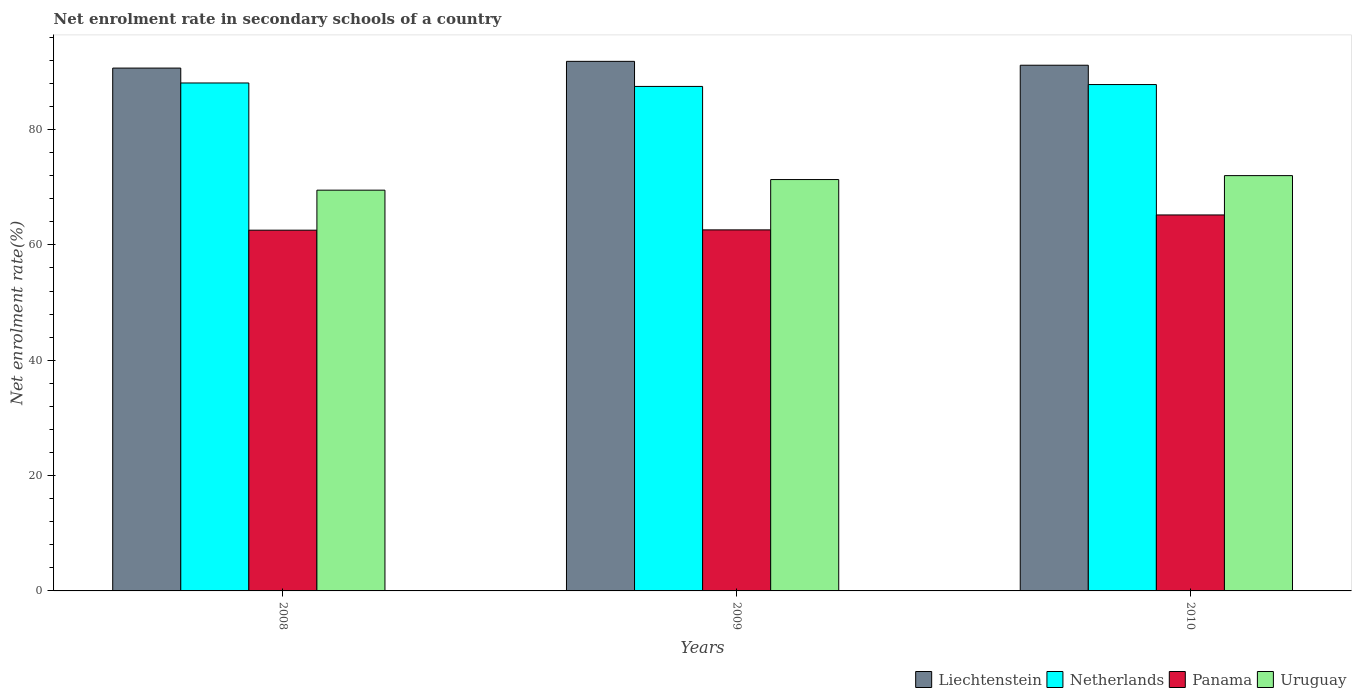How many different coloured bars are there?
Make the answer very short. 4. Are the number of bars per tick equal to the number of legend labels?
Offer a very short reply. Yes. How many bars are there on the 1st tick from the right?
Give a very brief answer. 4. What is the label of the 2nd group of bars from the left?
Make the answer very short. 2009. In how many cases, is the number of bars for a given year not equal to the number of legend labels?
Keep it short and to the point. 0. What is the net enrolment rate in secondary schools in Netherlands in 2010?
Ensure brevity in your answer.  87.8. Across all years, what is the maximum net enrolment rate in secondary schools in Netherlands?
Your answer should be very brief. 88.08. Across all years, what is the minimum net enrolment rate in secondary schools in Liechtenstein?
Your response must be concise. 90.66. In which year was the net enrolment rate in secondary schools in Uruguay minimum?
Your answer should be very brief. 2008. What is the total net enrolment rate in secondary schools in Uruguay in the graph?
Your answer should be compact. 212.83. What is the difference between the net enrolment rate in secondary schools in Panama in 2008 and that in 2010?
Keep it short and to the point. -2.64. What is the difference between the net enrolment rate in secondary schools in Uruguay in 2010 and the net enrolment rate in secondary schools in Netherlands in 2009?
Provide a succinct answer. -15.47. What is the average net enrolment rate in secondary schools in Panama per year?
Offer a terse response. 63.45. In the year 2008, what is the difference between the net enrolment rate in secondary schools in Netherlands and net enrolment rate in secondary schools in Uruguay?
Provide a short and direct response. 18.59. What is the ratio of the net enrolment rate in secondary schools in Liechtenstein in 2008 to that in 2010?
Make the answer very short. 0.99. Is the net enrolment rate in secondary schools in Panama in 2009 less than that in 2010?
Your answer should be very brief. Yes. Is the difference between the net enrolment rate in secondary schools in Netherlands in 2008 and 2010 greater than the difference between the net enrolment rate in secondary schools in Uruguay in 2008 and 2010?
Your answer should be compact. Yes. What is the difference between the highest and the second highest net enrolment rate in secondary schools in Panama?
Offer a very short reply. 2.59. What is the difference between the highest and the lowest net enrolment rate in secondary schools in Liechtenstein?
Offer a terse response. 1.17. What does the 4th bar from the left in 2008 represents?
Offer a very short reply. Uruguay. What does the 2nd bar from the right in 2008 represents?
Give a very brief answer. Panama. Is it the case that in every year, the sum of the net enrolment rate in secondary schools in Liechtenstein and net enrolment rate in secondary schools in Panama is greater than the net enrolment rate in secondary schools in Uruguay?
Your answer should be compact. Yes. How many bars are there?
Your answer should be very brief. 12. Are the values on the major ticks of Y-axis written in scientific E-notation?
Make the answer very short. No. Does the graph contain any zero values?
Ensure brevity in your answer.  No. Does the graph contain grids?
Give a very brief answer. No. What is the title of the graph?
Provide a short and direct response. Net enrolment rate in secondary schools of a country. What is the label or title of the X-axis?
Offer a very short reply. Years. What is the label or title of the Y-axis?
Keep it short and to the point. Net enrolment rate(%). What is the Net enrolment rate(%) of Liechtenstein in 2008?
Ensure brevity in your answer.  90.66. What is the Net enrolment rate(%) of Netherlands in 2008?
Ensure brevity in your answer.  88.08. What is the Net enrolment rate(%) of Panama in 2008?
Make the answer very short. 62.55. What is the Net enrolment rate(%) of Uruguay in 2008?
Keep it short and to the point. 69.49. What is the Net enrolment rate(%) of Liechtenstein in 2009?
Offer a terse response. 91.83. What is the Net enrolment rate(%) of Netherlands in 2009?
Keep it short and to the point. 87.48. What is the Net enrolment rate(%) in Panama in 2009?
Your answer should be compact. 62.6. What is the Net enrolment rate(%) in Uruguay in 2009?
Give a very brief answer. 71.33. What is the Net enrolment rate(%) of Liechtenstein in 2010?
Your answer should be very brief. 91.15. What is the Net enrolment rate(%) in Netherlands in 2010?
Offer a very short reply. 87.8. What is the Net enrolment rate(%) of Panama in 2010?
Give a very brief answer. 65.19. What is the Net enrolment rate(%) in Uruguay in 2010?
Keep it short and to the point. 72.01. Across all years, what is the maximum Net enrolment rate(%) of Liechtenstein?
Offer a very short reply. 91.83. Across all years, what is the maximum Net enrolment rate(%) in Netherlands?
Your answer should be compact. 88.08. Across all years, what is the maximum Net enrolment rate(%) in Panama?
Provide a short and direct response. 65.19. Across all years, what is the maximum Net enrolment rate(%) in Uruguay?
Keep it short and to the point. 72.01. Across all years, what is the minimum Net enrolment rate(%) of Liechtenstein?
Offer a terse response. 90.66. Across all years, what is the minimum Net enrolment rate(%) in Netherlands?
Ensure brevity in your answer.  87.48. Across all years, what is the minimum Net enrolment rate(%) of Panama?
Make the answer very short. 62.55. Across all years, what is the minimum Net enrolment rate(%) in Uruguay?
Provide a short and direct response. 69.49. What is the total Net enrolment rate(%) in Liechtenstein in the graph?
Your answer should be very brief. 273.64. What is the total Net enrolment rate(%) in Netherlands in the graph?
Ensure brevity in your answer.  263.36. What is the total Net enrolment rate(%) of Panama in the graph?
Offer a very short reply. 190.35. What is the total Net enrolment rate(%) of Uruguay in the graph?
Your answer should be compact. 212.83. What is the difference between the Net enrolment rate(%) of Liechtenstein in 2008 and that in 2009?
Your answer should be compact. -1.17. What is the difference between the Net enrolment rate(%) of Netherlands in 2008 and that in 2009?
Your answer should be compact. 0.6. What is the difference between the Net enrolment rate(%) in Panama in 2008 and that in 2009?
Make the answer very short. -0.05. What is the difference between the Net enrolment rate(%) of Uruguay in 2008 and that in 2009?
Ensure brevity in your answer.  -1.84. What is the difference between the Net enrolment rate(%) in Liechtenstein in 2008 and that in 2010?
Give a very brief answer. -0.49. What is the difference between the Net enrolment rate(%) in Netherlands in 2008 and that in 2010?
Provide a succinct answer. 0.27. What is the difference between the Net enrolment rate(%) in Panama in 2008 and that in 2010?
Keep it short and to the point. -2.64. What is the difference between the Net enrolment rate(%) in Uruguay in 2008 and that in 2010?
Ensure brevity in your answer.  -2.52. What is the difference between the Net enrolment rate(%) in Liechtenstein in 2009 and that in 2010?
Provide a succinct answer. 0.67. What is the difference between the Net enrolment rate(%) in Netherlands in 2009 and that in 2010?
Ensure brevity in your answer.  -0.33. What is the difference between the Net enrolment rate(%) of Panama in 2009 and that in 2010?
Provide a short and direct response. -2.59. What is the difference between the Net enrolment rate(%) of Uruguay in 2009 and that in 2010?
Provide a succinct answer. -0.68. What is the difference between the Net enrolment rate(%) in Liechtenstein in 2008 and the Net enrolment rate(%) in Netherlands in 2009?
Ensure brevity in your answer.  3.18. What is the difference between the Net enrolment rate(%) in Liechtenstein in 2008 and the Net enrolment rate(%) in Panama in 2009?
Provide a short and direct response. 28.06. What is the difference between the Net enrolment rate(%) of Liechtenstein in 2008 and the Net enrolment rate(%) of Uruguay in 2009?
Provide a succinct answer. 19.33. What is the difference between the Net enrolment rate(%) in Netherlands in 2008 and the Net enrolment rate(%) in Panama in 2009?
Your answer should be compact. 25.47. What is the difference between the Net enrolment rate(%) in Netherlands in 2008 and the Net enrolment rate(%) in Uruguay in 2009?
Provide a short and direct response. 16.75. What is the difference between the Net enrolment rate(%) in Panama in 2008 and the Net enrolment rate(%) in Uruguay in 2009?
Your response must be concise. -8.78. What is the difference between the Net enrolment rate(%) of Liechtenstein in 2008 and the Net enrolment rate(%) of Netherlands in 2010?
Provide a short and direct response. 2.86. What is the difference between the Net enrolment rate(%) of Liechtenstein in 2008 and the Net enrolment rate(%) of Panama in 2010?
Your answer should be compact. 25.47. What is the difference between the Net enrolment rate(%) in Liechtenstein in 2008 and the Net enrolment rate(%) in Uruguay in 2010?
Your answer should be compact. 18.65. What is the difference between the Net enrolment rate(%) of Netherlands in 2008 and the Net enrolment rate(%) of Panama in 2010?
Your answer should be very brief. 22.88. What is the difference between the Net enrolment rate(%) of Netherlands in 2008 and the Net enrolment rate(%) of Uruguay in 2010?
Give a very brief answer. 16.06. What is the difference between the Net enrolment rate(%) in Panama in 2008 and the Net enrolment rate(%) in Uruguay in 2010?
Keep it short and to the point. -9.46. What is the difference between the Net enrolment rate(%) in Liechtenstein in 2009 and the Net enrolment rate(%) in Netherlands in 2010?
Ensure brevity in your answer.  4.02. What is the difference between the Net enrolment rate(%) in Liechtenstein in 2009 and the Net enrolment rate(%) in Panama in 2010?
Your response must be concise. 26.63. What is the difference between the Net enrolment rate(%) in Liechtenstein in 2009 and the Net enrolment rate(%) in Uruguay in 2010?
Your response must be concise. 19.81. What is the difference between the Net enrolment rate(%) of Netherlands in 2009 and the Net enrolment rate(%) of Panama in 2010?
Your answer should be very brief. 22.29. What is the difference between the Net enrolment rate(%) of Netherlands in 2009 and the Net enrolment rate(%) of Uruguay in 2010?
Your response must be concise. 15.47. What is the difference between the Net enrolment rate(%) of Panama in 2009 and the Net enrolment rate(%) of Uruguay in 2010?
Your response must be concise. -9.41. What is the average Net enrolment rate(%) of Liechtenstein per year?
Give a very brief answer. 91.21. What is the average Net enrolment rate(%) of Netherlands per year?
Your answer should be very brief. 87.79. What is the average Net enrolment rate(%) of Panama per year?
Your answer should be compact. 63.45. What is the average Net enrolment rate(%) in Uruguay per year?
Keep it short and to the point. 70.94. In the year 2008, what is the difference between the Net enrolment rate(%) in Liechtenstein and Net enrolment rate(%) in Netherlands?
Your response must be concise. 2.58. In the year 2008, what is the difference between the Net enrolment rate(%) of Liechtenstein and Net enrolment rate(%) of Panama?
Your response must be concise. 28.11. In the year 2008, what is the difference between the Net enrolment rate(%) in Liechtenstein and Net enrolment rate(%) in Uruguay?
Provide a short and direct response. 21.17. In the year 2008, what is the difference between the Net enrolment rate(%) of Netherlands and Net enrolment rate(%) of Panama?
Give a very brief answer. 25.52. In the year 2008, what is the difference between the Net enrolment rate(%) in Netherlands and Net enrolment rate(%) in Uruguay?
Your response must be concise. 18.59. In the year 2008, what is the difference between the Net enrolment rate(%) in Panama and Net enrolment rate(%) in Uruguay?
Provide a succinct answer. -6.94. In the year 2009, what is the difference between the Net enrolment rate(%) of Liechtenstein and Net enrolment rate(%) of Netherlands?
Your answer should be very brief. 4.35. In the year 2009, what is the difference between the Net enrolment rate(%) in Liechtenstein and Net enrolment rate(%) in Panama?
Your answer should be compact. 29.22. In the year 2009, what is the difference between the Net enrolment rate(%) of Liechtenstein and Net enrolment rate(%) of Uruguay?
Your answer should be compact. 20.5. In the year 2009, what is the difference between the Net enrolment rate(%) in Netherlands and Net enrolment rate(%) in Panama?
Keep it short and to the point. 24.88. In the year 2009, what is the difference between the Net enrolment rate(%) in Netherlands and Net enrolment rate(%) in Uruguay?
Give a very brief answer. 16.15. In the year 2009, what is the difference between the Net enrolment rate(%) of Panama and Net enrolment rate(%) of Uruguay?
Ensure brevity in your answer.  -8.73. In the year 2010, what is the difference between the Net enrolment rate(%) in Liechtenstein and Net enrolment rate(%) in Netherlands?
Make the answer very short. 3.35. In the year 2010, what is the difference between the Net enrolment rate(%) in Liechtenstein and Net enrolment rate(%) in Panama?
Your response must be concise. 25.96. In the year 2010, what is the difference between the Net enrolment rate(%) in Liechtenstein and Net enrolment rate(%) in Uruguay?
Your response must be concise. 19.14. In the year 2010, what is the difference between the Net enrolment rate(%) of Netherlands and Net enrolment rate(%) of Panama?
Provide a short and direct response. 22.61. In the year 2010, what is the difference between the Net enrolment rate(%) in Netherlands and Net enrolment rate(%) in Uruguay?
Provide a short and direct response. 15.79. In the year 2010, what is the difference between the Net enrolment rate(%) of Panama and Net enrolment rate(%) of Uruguay?
Ensure brevity in your answer.  -6.82. What is the ratio of the Net enrolment rate(%) in Liechtenstein in 2008 to that in 2009?
Offer a very short reply. 0.99. What is the ratio of the Net enrolment rate(%) of Netherlands in 2008 to that in 2009?
Your response must be concise. 1.01. What is the ratio of the Net enrolment rate(%) in Panama in 2008 to that in 2009?
Offer a very short reply. 1. What is the ratio of the Net enrolment rate(%) of Uruguay in 2008 to that in 2009?
Your response must be concise. 0.97. What is the ratio of the Net enrolment rate(%) of Liechtenstein in 2008 to that in 2010?
Your answer should be very brief. 0.99. What is the ratio of the Net enrolment rate(%) in Netherlands in 2008 to that in 2010?
Provide a short and direct response. 1. What is the ratio of the Net enrolment rate(%) of Panama in 2008 to that in 2010?
Your answer should be very brief. 0.96. What is the ratio of the Net enrolment rate(%) in Liechtenstein in 2009 to that in 2010?
Offer a very short reply. 1.01. What is the ratio of the Net enrolment rate(%) in Panama in 2009 to that in 2010?
Keep it short and to the point. 0.96. What is the difference between the highest and the second highest Net enrolment rate(%) in Liechtenstein?
Offer a terse response. 0.67. What is the difference between the highest and the second highest Net enrolment rate(%) in Netherlands?
Ensure brevity in your answer.  0.27. What is the difference between the highest and the second highest Net enrolment rate(%) of Panama?
Offer a very short reply. 2.59. What is the difference between the highest and the second highest Net enrolment rate(%) in Uruguay?
Provide a short and direct response. 0.68. What is the difference between the highest and the lowest Net enrolment rate(%) in Liechtenstein?
Your response must be concise. 1.17. What is the difference between the highest and the lowest Net enrolment rate(%) of Netherlands?
Provide a short and direct response. 0.6. What is the difference between the highest and the lowest Net enrolment rate(%) in Panama?
Your answer should be very brief. 2.64. What is the difference between the highest and the lowest Net enrolment rate(%) in Uruguay?
Offer a very short reply. 2.52. 